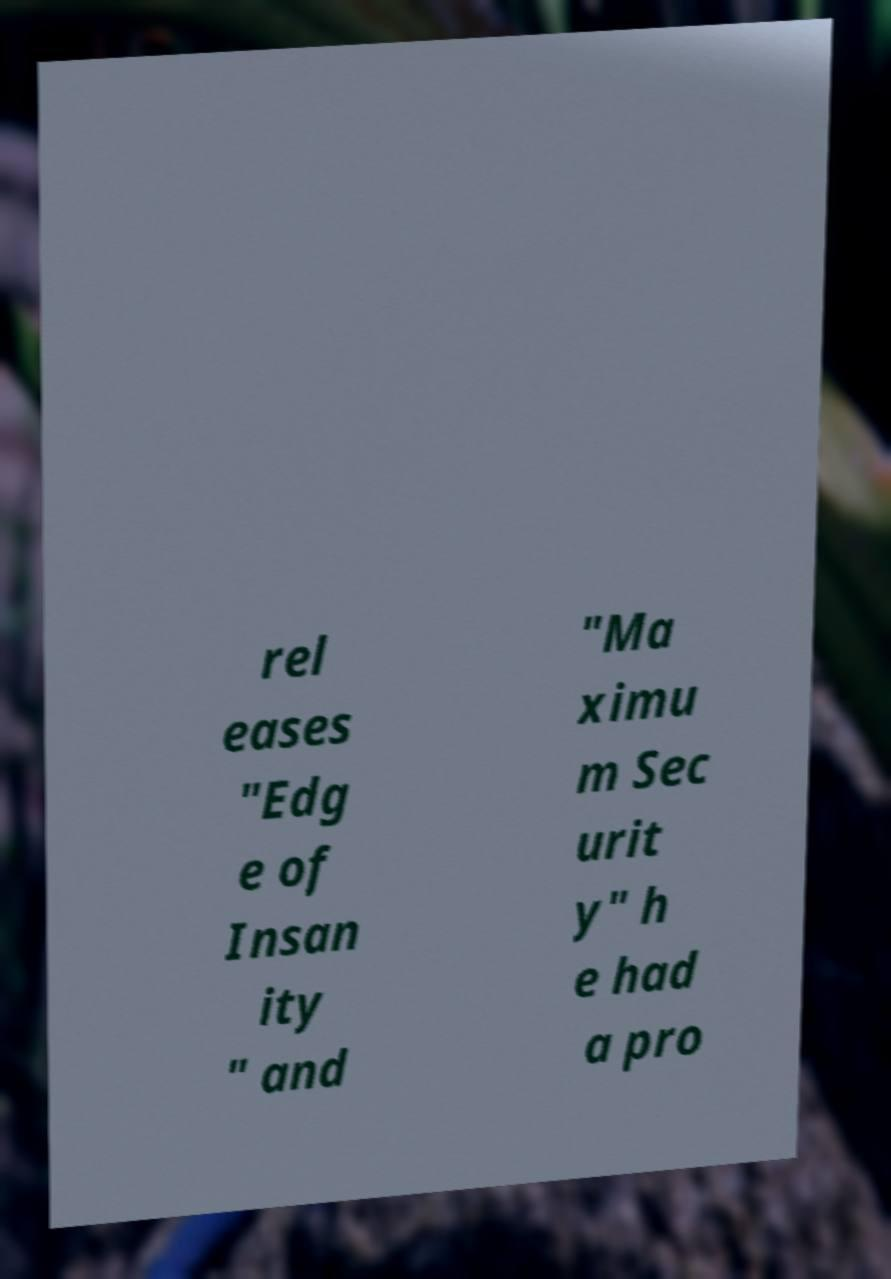Could you assist in decoding the text presented in this image and type it out clearly? rel eases "Edg e of Insan ity " and "Ma ximu m Sec urit y" h e had a pro 